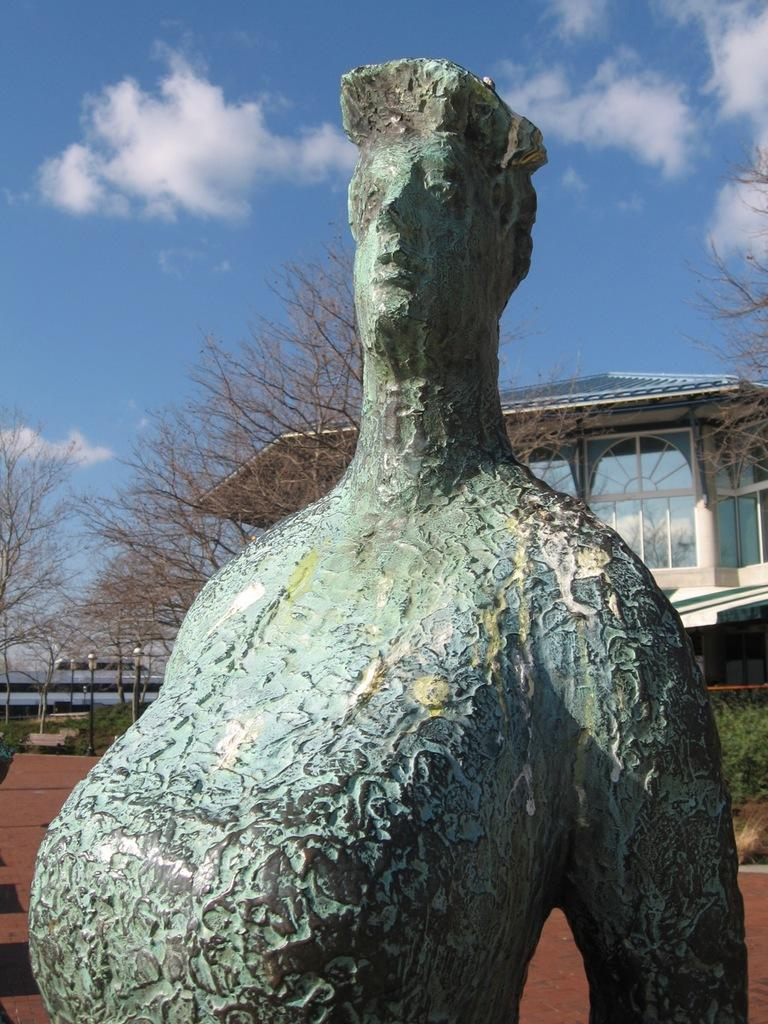What is the main subject of the image? There is a statue of a person in the image. What can be seen in the background of the image? There are trees, at least one building, pole lights, and other objects visible in the background. What is the condition of the sky in the image? The sky is visible in the background of the image. What type of loaf is being offered by the statue in the image? There is no loaf present in the image; the main subject is a statue of a person. Who is the creator of the statue in the image? The creator of the statue is not mentioned in the image, so it cannot be determined from the image alone. 